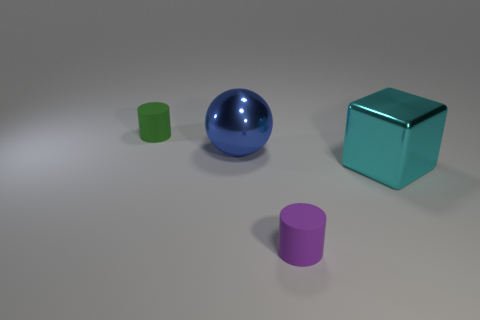Add 1 small purple cylinders. How many objects exist? 5 Subtract all green cylinders. How many cylinders are left? 1 Add 1 tiny yellow metallic objects. How many tiny yellow metallic objects exist? 1 Subtract 0 red blocks. How many objects are left? 4 Subtract all spheres. How many objects are left? 3 Subtract 1 blocks. How many blocks are left? 0 Subtract all yellow spheres. Subtract all blue cylinders. How many spheres are left? 1 Subtract all brown spheres. How many green cylinders are left? 1 Subtract all large green balls. Subtract all large balls. How many objects are left? 3 Add 4 big blue shiny spheres. How many big blue shiny spheres are left? 5 